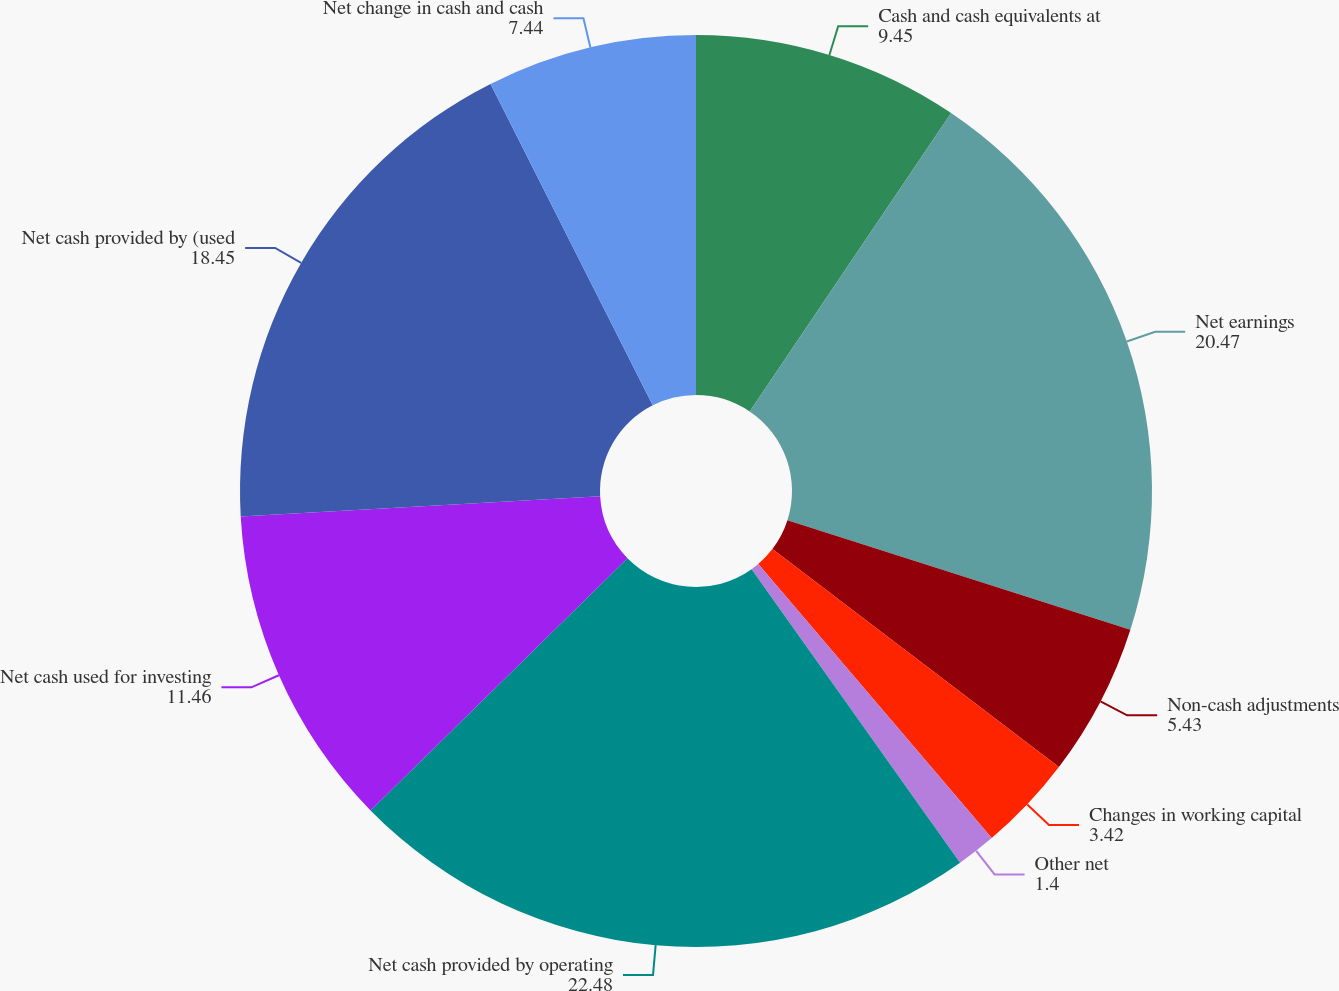<chart> <loc_0><loc_0><loc_500><loc_500><pie_chart><fcel>Cash and cash equivalents at<fcel>Net earnings<fcel>Non-cash adjustments<fcel>Changes in working capital<fcel>Other net<fcel>Net cash provided by operating<fcel>Net cash used for investing<fcel>Net cash provided by (used<fcel>Net change in cash and cash<nl><fcel>9.45%<fcel>20.47%<fcel>5.43%<fcel>3.42%<fcel>1.4%<fcel>22.48%<fcel>11.46%<fcel>18.45%<fcel>7.44%<nl></chart> 